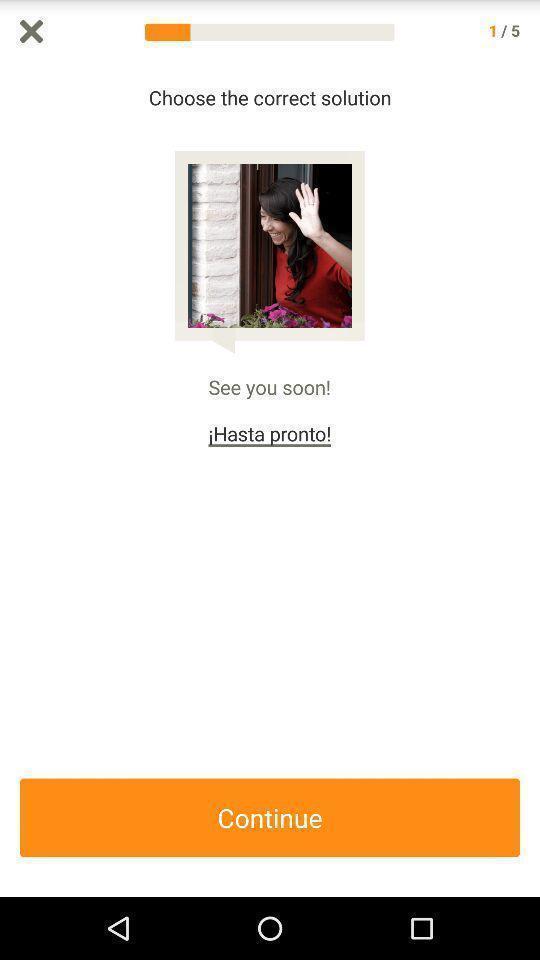Describe the visual elements of this screenshot. Screen shows option to continue with an app. 